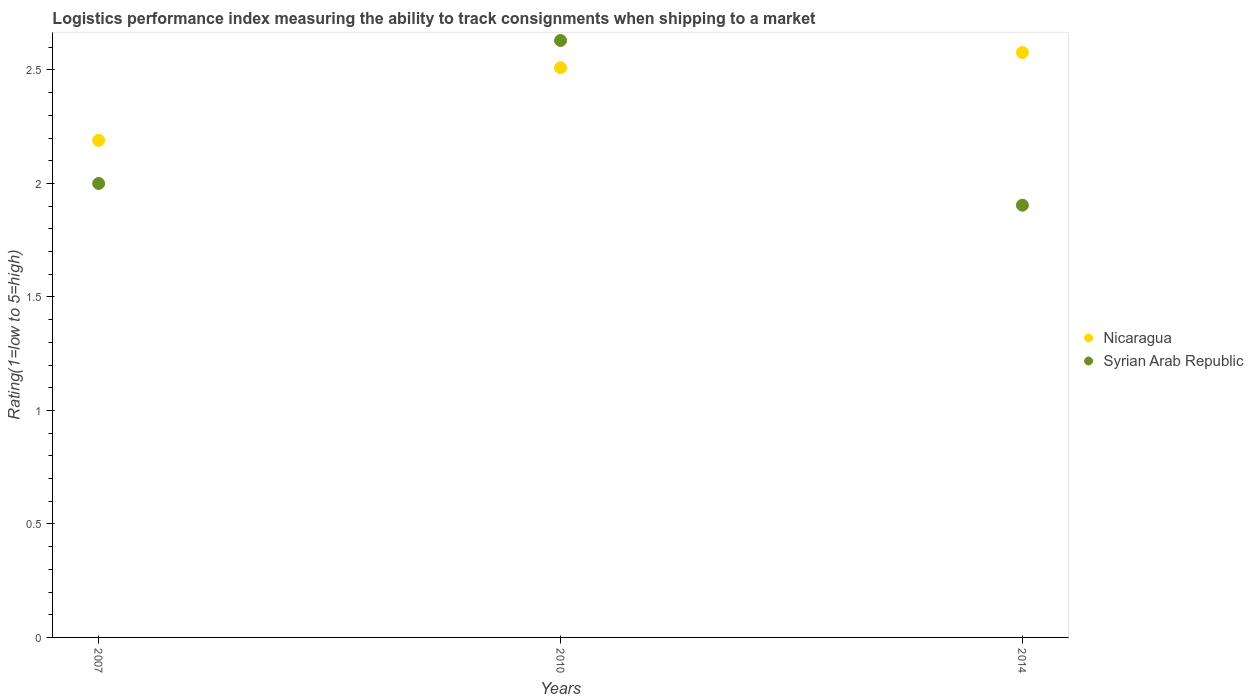Is the number of dotlines equal to the number of legend labels?
Offer a terse response. Yes. What is the Logistic performance index in Nicaragua in 2014?
Ensure brevity in your answer.  2.58. Across all years, what is the maximum Logistic performance index in Syrian Arab Republic?
Offer a terse response. 2.63. Across all years, what is the minimum Logistic performance index in Nicaragua?
Offer a terse response. 2.19. In which year was the Logistic performance index in Syrian Arab Republic minimum?
Provide a short and direct response. 2014. What is the total Logistic performance index in Syrian Arab Republic in the graph?
Provide a succinct answer. 6.53. What is the difference between the Logistic performance index in Nicaragua in 2007 and that in 2010?
Your answer should be very brief. -0.32. What is the difference between the Logistic performance index in Syrian Arab Republic in 2010 and the Logistic performance index in Nicaragua in 2007?
Your response must be concise. 0.44. What is the average Logistic performance index in Nicaragua per year?
Provide a succinct answer. 2.43. In the year 2010, what is the difference between the Logistic performance index in Nicaragua and Logistic performance index in Syrian Arab Republic?
Your answer should be compact. -0.12. In how many years, is the Logistic performance index in Nicaragua greater than 1.5?
Offer a terse response. 3. What is the ratio of the Logistic performance index in Syrian Arab Republic in 2007 to that in 2010?
Your response must be concise. 0.76. What is the difference between the highest and the second highest Logistic performance index in Syrian Arab Republic?
Offer a terse response. 0.63. What is the difference between the highest and the lowest Logistic performance index in Syrian Arab Republic?
Your response must be concise. 0.73. Is the Logistic performance index in Nicaragua strictly greater than the Logistic performance index in Syrian Arab Republic over the years?
Offer a terse response. No. Is the Logistic performance index in Syrian Arab Republic strictly less than the Logistic performance index in Nicaragua over the years?
Your response must be concise. No. How many dotlines are there?
Provide a short and direct response. 2. How many years are there in the graph?
Offer a very short reply. 3. What is the difference between two consecutive major ticks on the Y-axis?
Ensure brevity in your answer.  0.5. Are the values on the major ticks of Y-axis written in scientific E-notation?
Make the answer very short. No. Where does the legend appear in the graph?
Give a very brief answer. Center right. How many legend labels are there?
Your answer should be very brief. 2. What is the title of the graph?
Give a very brief answer. Logistics performance index measuring the ability to track consignments when shipping to a market. Does "Mongolia" appear as one of the legend labels in the graph?
Your answer should be compact. No. What is the label or title of the X-axis?
Your answer should be very brief. Years. What is the label or title of the Y-axis?
Make the answer very short. Rating(1=low to 5=high). What is the Rating(1=low to 5=high) in Nicaragua in 2007?
Your answer should be compact. 2.19. What is the Rating(1=low to 5=high) of Syrian Arab Republic in 2007?
Your response must be concise. 2. What is the Rating(1=low to 5=high) of Nicaragua in 2010?
Provide a succinct answer. 2.51. What is the Rating(1=low to 5=high) in Syrian Arab Republic in 2010?
Your answer should be compact. 2.63. What is the Rating(1=low to 5=high) in Nicaragua in 2014?
Offer a terse response. 2.58. What is the Rating(1=low to 5=high) of Syrian Arab Republic in 2014?
Provide a succinct answer. 1.9. Across all years, what is the maximum Rating(1=low to 5=high) in Nicaragua?
Offer a very short reply. 2.58. Across all years, what is the maximum Rating(1=low to 5=high) in Syrian Arab Republic?
Keep it short and to the point. 2.63. Across all years, what is the minimum Rating(1=low to 5=high) in Nicaragua?
Your response must be concise. 2.19. Across all years, what is the minimum Rating(1=low to 5=high) of Syrian Arab Republic?
Make the answer very short. 1.9. What is the total Rating(1=low to 5=high) of Nicaragua in the graph?
Provide a short and direct response. 7.28. What is the total Rating(1=low to 5=high) in Syrian Arab Republic in the graph?
Your answer should be compact. 6.53. What is the difference between the Rating(1=low to 5=high) of Nicaragua in 2007 and that in 2010?
Provide a short and direct response. -0.32. What is the difference between the Rating(1=low to 5=high) of Syrian Arab Republic in 2007 and that in 2010?
Give a very brief answer. -0.63. What is the difference between the Rating(1=low to 5=high) in Nicaragua in 2007 and that in 2014?
Provide a succinct answer. -0.39. What is the difference between the Rating(1=low to 5=high) of Syrian Arab Republic in 2007 and that in 2014?
Provide a succinct answer. 0.1. What is the difference between the Rating(1=low to 5=high) in Nicaragua in 2010 and that in 2014?
Your answer should be compact. -0.07. What is the difference between the Rating(1=low to 5=high) of Syrian Arab Republic in 2010 and that in 2014?
Give a very brief answer. 0.73. What is the difference between the Rating(1=low to 5=high) in Nicaragua in 2007 and the Rating(1=low to 5=high) in Syrian Arab Republic in 2010?
Make the answer very short. -0.44. What is the difference between the Rating(1=low to 5=high) in Nicaragua in 2007 and the Rating(1=low to 5=high) in Syrian Arab Republic in 2014?
Provide a short and direct response. 0.29. What is the difference between the Rating(1=low to 5=high) in Nicaragua in 2010 and the Rating(1=low to 5=high) in Syrian Arab Republic in 2014?
Keep it short and to the point. 0.61. What is the average Rating(1=low to 5=high) of Nicaragua per year?
Offer a very short reply. 2.43. What is the average Rating(1=low to 5=high) in Syrian Arab Republic per year?
Make the answer very short. 2.18. In the year 2007, what is the difference between the Rating(1=low to 5=high) in Nicaragua and Rating(1=low to 5=high) in Syrian Arab Republic?
Make the answer very short. 0.19. In the year 2010, what is the difference between the Rating(1=low to 5=high) in Nicaragua and Rating(1=low to 5=high) in Syrian Arab Republic?
Your answer should be compact. -0.12. In the year 2014, what is the difference between the Rating(1=low to 5=high) of Nicaragua and Rating(1=low to 5=high) of Syrian Arab Republic?
Provide a short and direct response. 0.67. What is the ratio of the Rating(1=low to 5=high) in Nicaragua in 2007 to that in 2010?
Your response must be concise. 0.87. What is the ratio of the Rating(1=low to 5=high) in Syrian Arab Republic in 2007 to that in 2010?
Your response must be concise. 0.76. What is the ratio of the Rating(1=low to 5=high) of Nicaragua in 2007 to that in 2014?
Your answer should be very brief. 0.85. What is the ratio of the Rating(1=low to 5=high) of Syrian Arab Republic in 2007 to that in 2014?
Your answer should be very brief. 1.05. What is the ratio of the Rating(1=low to 5=high) in Nicaragua in 2010 to that in 2014?
Your response must be concise. 0.97. What is the ratio of the Rating(1=low to 5=high) of Syrian Arab Republic in 2010 to that in 2014?
Keep it short and to the point. 1.38. What is the difference between the highest and the second highest Rating(1=low to 5=high) of Nicaragua?
Provide a succinct answer. 0.07. What is the difference between the highest and the second highest Rating(1=low to 5=high) of Syrian Arab Republic?
Offer a very short reply. 0.63. What is the difference between the highest and the lowest Rating(1=low to 5=high) of Nicaragua?
Keep it short and to the point. 0.39. What is the difference between the highest and the lowest Rating(1=low to 5=high) in Syrian Arab Republic?
Give a very brief answer. 0.73. 